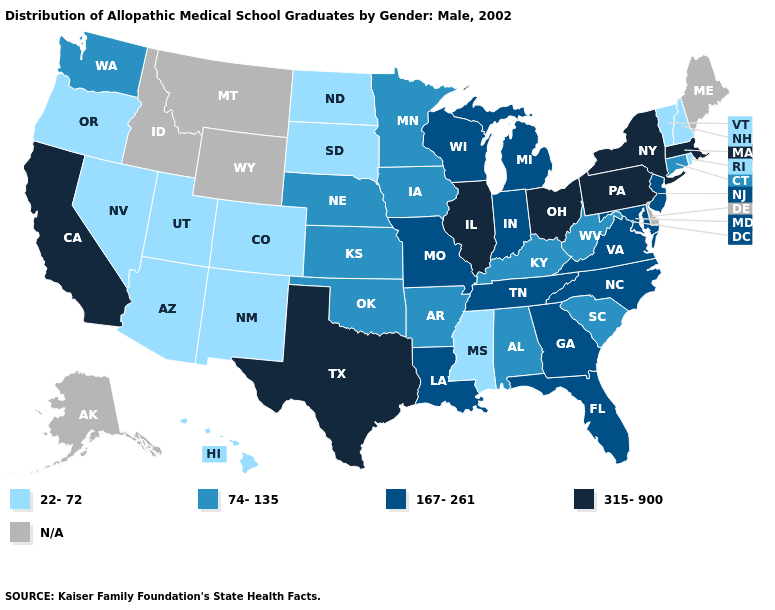What is the value of Nevada?
Concise answer only. 22-72. What is the lowest value in states that border North Dakota?
Write a very short answer. 22-72. Does the map have missing data?
Quick response, please. Yes. Which states have the highest value in the USA?
Give a very brief answer. California, Illinois, Massachusetts, New York, Ohio, Pennsylvania, Texas. Which states have the highest value in the USA?
Keep it brief. California, Illinois, Massachusetts, New York, Ohio, Pennsylvania, Texas. Which states have the lowest value in the USA?
Be succinct. Arizona, Colorado, Hawaii, Mississippi, Nevada, New Hampshire, New Mexico, North Dakota, Oregon, Rhode Island, South Dakota, Utah, Vermont. What is the value of West Virginia?
Short answer required. 74-135. What is the lowest value in the USA?
Concise answer only. 22-72. What is the lowest value in the West?
Quick response, please. 22-72. Name the states that have a value in the range 167-261?
Answer briefly. Florida, Georgia, Indiana, Louisiana, Maryland, Michigan, Missouri, New Jersey, North Carolina, Tennessee, Virginia, Wisconsin. Among the states that border Oklahoma , which have the lowest value?
Answer briefly. Colorado, New Mexico. What is the value of Arkansas?
Keep it brief. 74-135. What is the value of Kansas?
Concise answer only. 74-135. What is the highest value in states that border Michigan?
Be succinct. 315-900. 